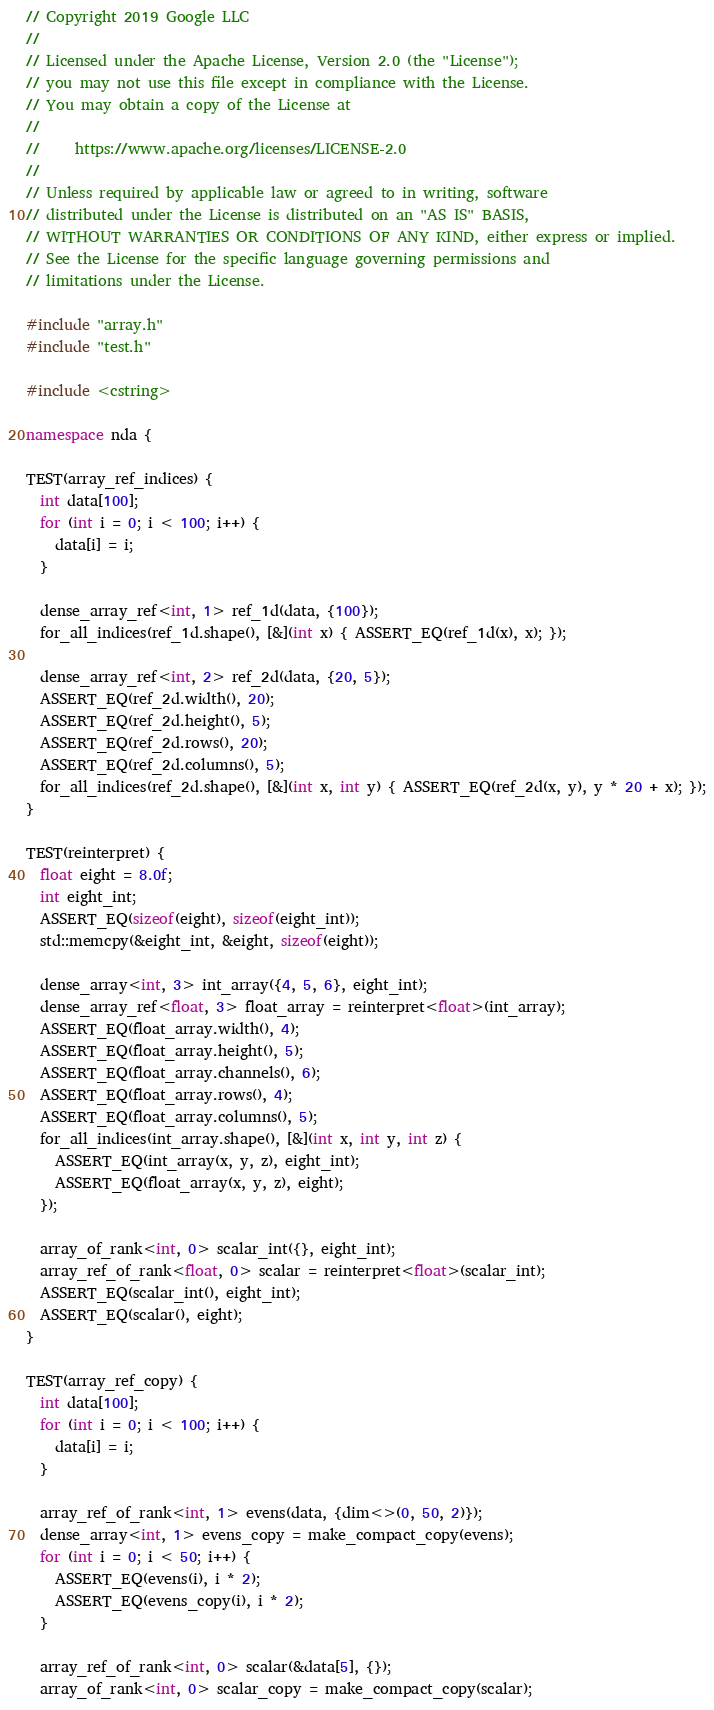<code> <loc_0><loc_0><loc_500><loc_500><_C++_>// Copyright 2019 Google LLC
//
// Licensed under the Apache License, Version 2.0 (the "License");
// you may not use this file except in compliance with the License.
// You may obtain a copy of the License at
//
//     https://www.apache.org/licenses/LICENSE-2.0
//
// Unless required by applicable law or agreed to in writing, software
// distributed under the License is distributed on an "AS IS" BASIS,
// WITHOUT WARRANTIES OR CONDITIONS OF ANY KIND, either express or implied.
// See the License for the specific language governing permissions and
// limitations under the License.

#include "array.h"
#include "test.h"

#include <cstring>

namespace nda {

TEST(array_ref_indices) {
  int data[100];
  for (int i = 0; i < 100; i++) {
    data[i] = i;
  }

  dense_array_ref<int, 1> ref_1d(data, {100});
  for_all_indices(ref_1d.shape(), [&](int x) { ASSERT_EQ(ref_1d(x), x); });

  dense_array_ref<int, 2> ref_2d(data, {20, 5});
  ASSERT_EQ(ref_2d.width(), 20);
  ASSERT_EQ(ref_2d.height(), 5);
  ASSERT_EQ(ref_2d.rows(), 20);
  ASSERT_EQ(ref_2d.columns(), 5);
  for_all_indices(ref_2d.shape(), [&](int x, int y) { ASSERT_EQ(ref_2d(x, y), y * 20 + x); });
}

TEST(reinterpret) {
  float eight = 8.0f;
  int eight_int;
  ASSERT_EQ(sizeof(eight), sizeof(eight_int));
  std::memcpy(&eight_int, &eight, sizeof(eight));

  dense_array<int, 3> int_array({4, 5, 6}, eight_int);
  dense_array_ref<float, 3> float_array = reinterpret<float>(int_array);
  ASSERT_EQ(float_array.width(), 4);
  ASSERT_EQ(float_array.height(), 5);
  ASSERT_EQ(float_array.channels(), 6);
  ASSERT_EQ(float_array.rows(), 4);
  ASSERT_EQ(float_array.columns(), 5);
  for_all_indices(int_array.shape(), [&](int x, int y, int z) {
    ASSERT_EQ(int_array(x, y, z), eight_int);
    ASSERT_EQ(float_array(x, y, z), eight);
  });

  array_of_rank<int, 0> scalar_int({}, eight_int);
  array_ref_of_rank<float, 0> scalar = reinterpret<float>(scalar_int);
  ASSERT_EQ(scalar_int(), eight_int);
  ASSERT_EQ(scalar(), eight);
}

TEST(array_ref_copy) {
  int data[100];
  for (int i = 0; i < 100; i++) {
    data[i] = i;
  }

  array_ref_of_rank<int, 1> evens(data, {dim<>(0, 50, 2)});
  dense_array<int, 1> evens_copy = make_compact_copy(evens);
  for (int i = 0; i < 50; i++) {
    ASSERT_EQ(evens(i), i * 2);
    ASSERT_EQ(evens_copy(i), i * 2);
  }

  array_ref_of_rank<int, 0> scalar(&data[5], {});
  array_of_rank<int, 0> scalar_copy = make_compact_copy(scalar);</code> 